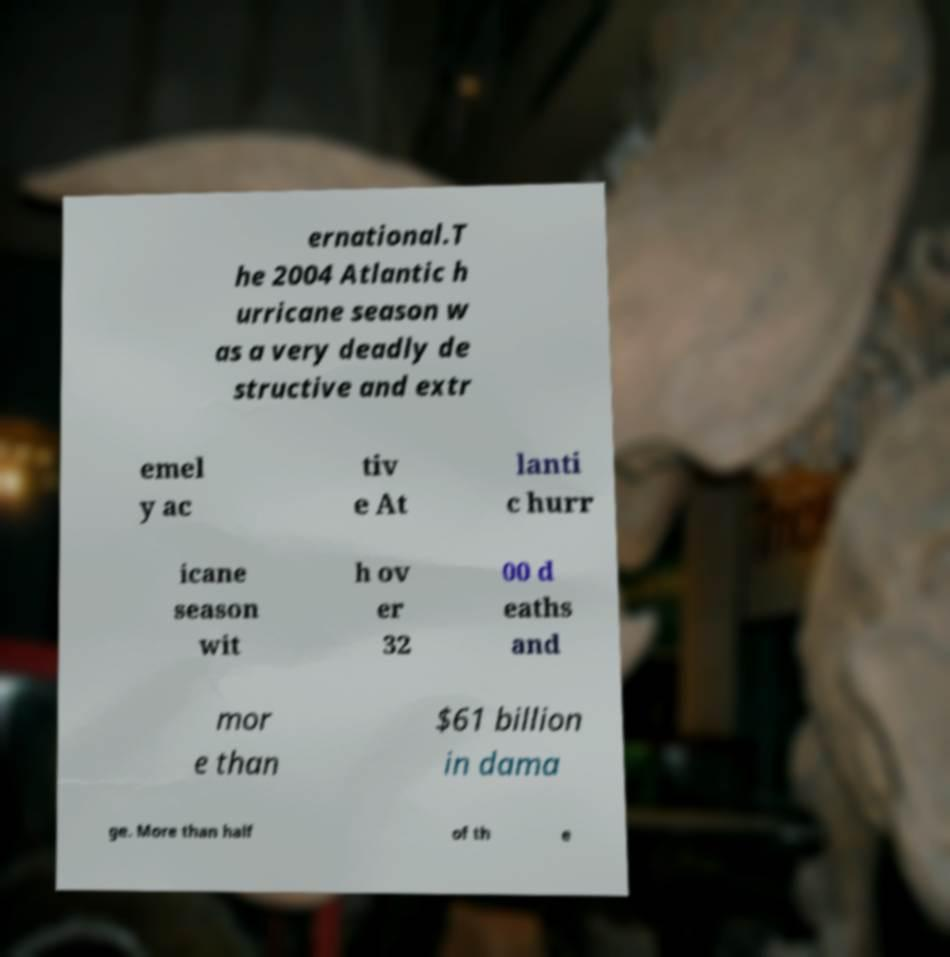Can you accurately transcribe the text from the provided image for me? ernational.T he 2004 Atlantic h urricane season w as a very deadly de structive and extr emel y ac tiv e At lanti c hurr icane season wit h ov er 32 00 d eaths and mor e than $61 billion in dama ge. More than half of th e 